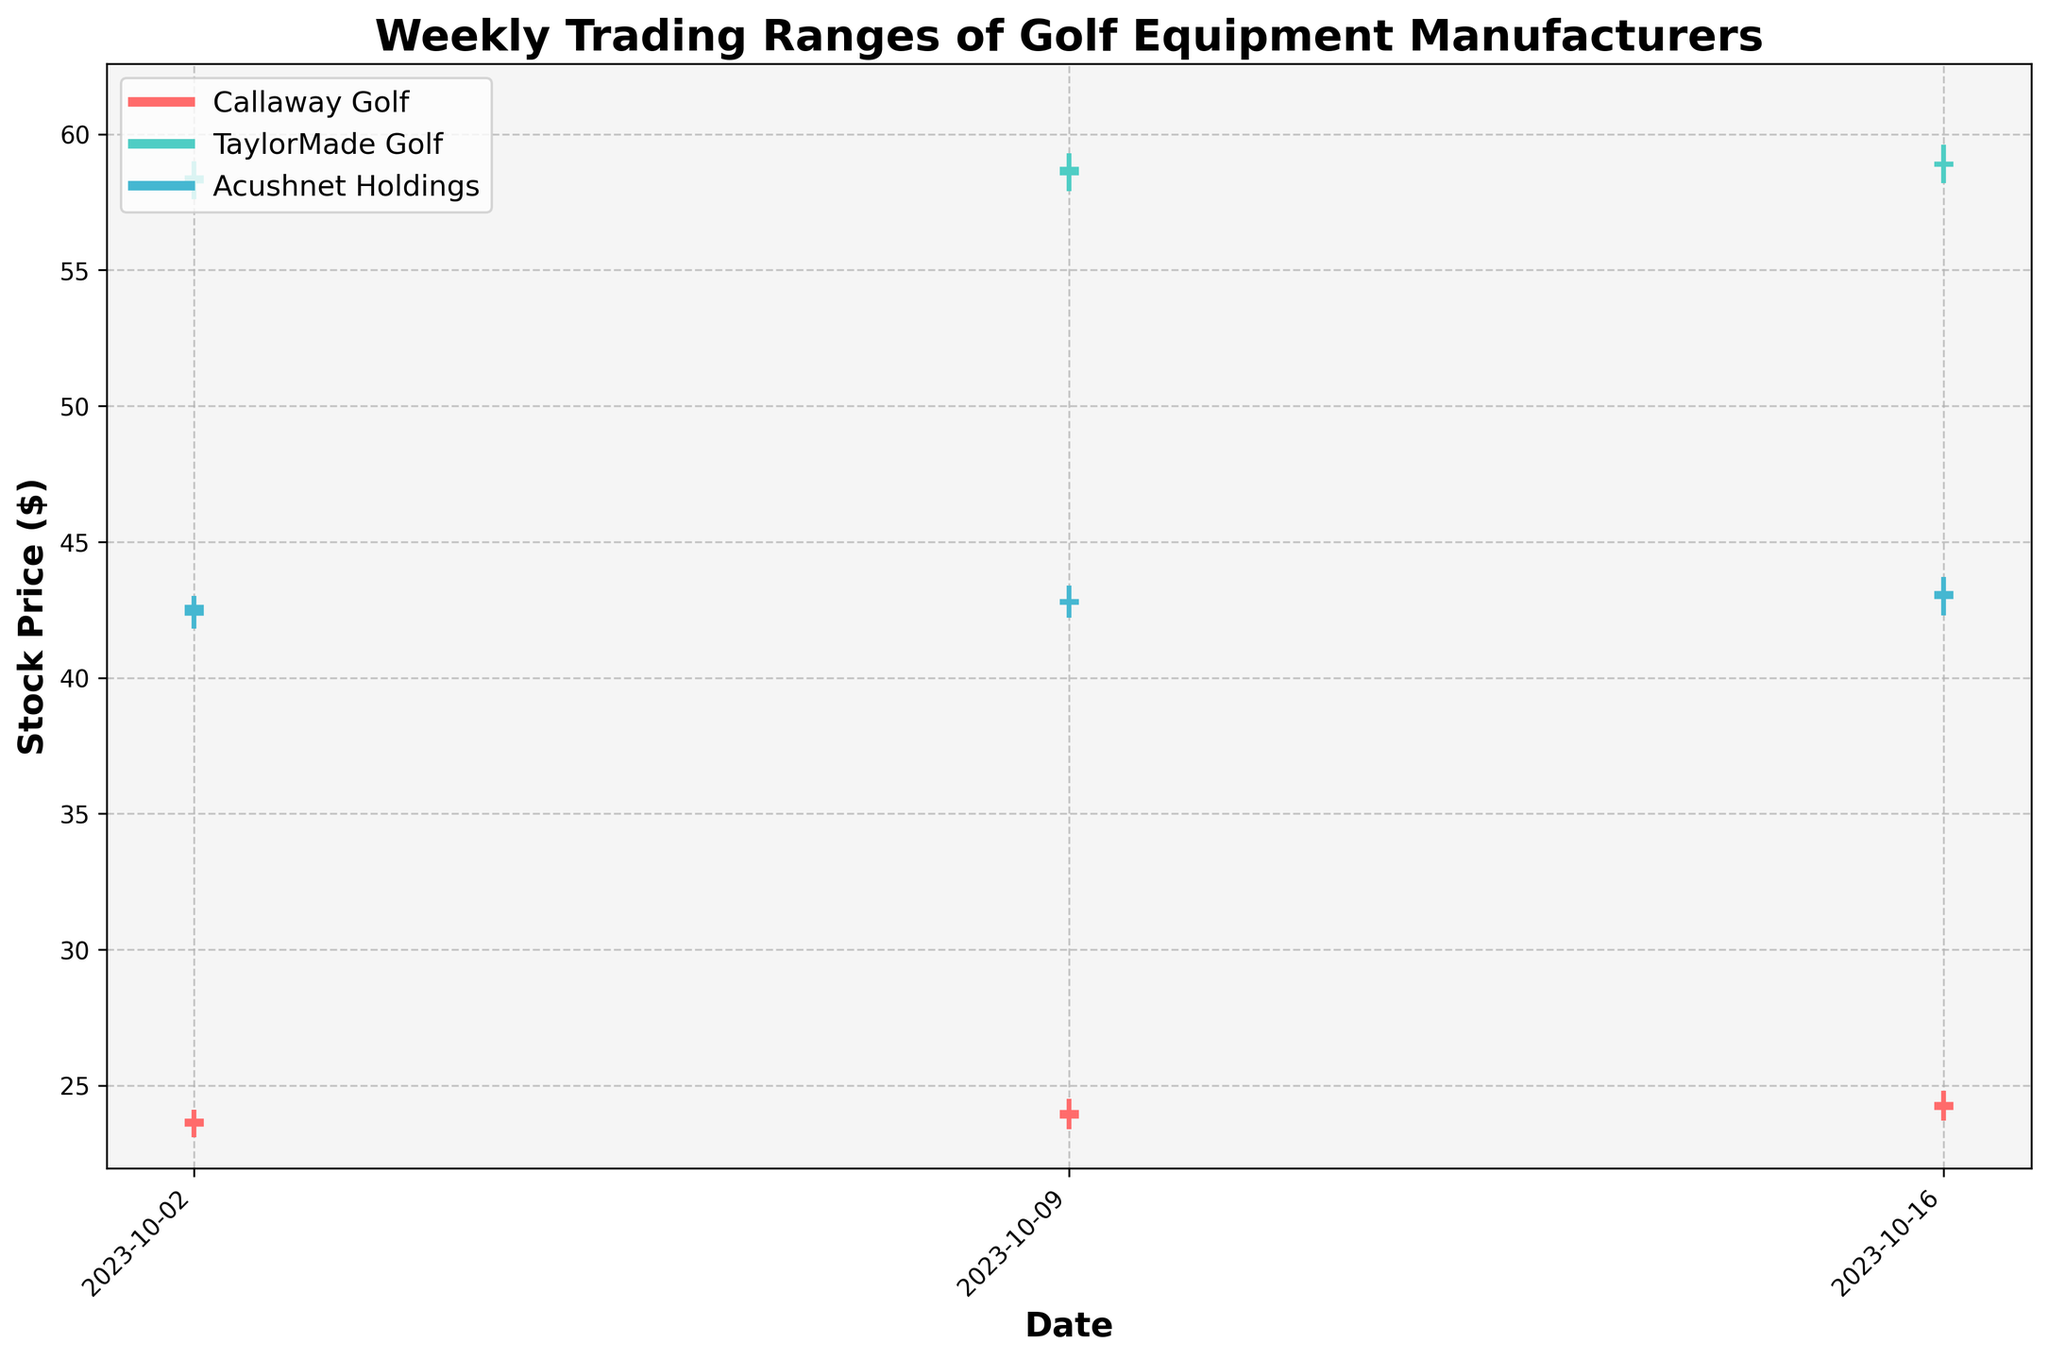What is the title of the candlestick plot? The title is usually placed at the top of the plot. In this case, the title is "Weekly Trading Ranges of Golf Equipment Manufacturers" to describe the subject of the plot.
Answer: Weekly Trading Ranges of Golf Equipment Manufacturers Which company had the highest closing price on October 16, 2023? To determine the highest closing price, look at the closing prices on October 16, 2023, for each company. The closing prices are 24.40 for Callaway Golf, 59.00 for TaylorMade Golf, and 43.20 for Acushnet Holdings. TaylorMade Golf has the highest closing price.
Answer: TaylorMade Golf What is the trading volume for Callaway Golf on October 9, 2023? The volume for each company on a specific date is usually shown in the data. On October 9, 2023, Callaway Golf's trading volume is listed as 130,000.
Answer: 130,000 Which date showed the narrowest trading range for Acushnet Holdings? To find the narrowest trading range, compute the difference between the High and Low prices for Acushnet Holdings on each date. The ranges are (43.00 - 41.80 = 1.20) on October 2, (43.40 - 42.20 = 1.20) on October 9, and (43.70 - 42.30 = 1.40) on October 16. The smallest range is 1.20, which occurs on both October 2 and October 9.
Answer: October 2 and 9 Compare the opening prices of TaylorMade Golf on October 2, October 9, and October 16, 2023, and identify the trend. The opening prices for TaylorMade Golf are 58.20 on October 2, 58.50 on October 9, and 58.80 on October 16. We observe that the opening price increased each week.
Answer: Increasing What is the average closing price of the three companies on October 9, 2023? Sum the closing prices for each company on October 9: 24.10 (Callaway) + 58.80 (TaylorMade) + 42.90 (Acushnet). The sum is 125.80. Divide by the number of companies (3) to get the average: 125.80 / 3 = 41.93.
Answer: 41.93 Which company had the highest weekly trading volume overall? Compare the total trading volumes for each company across all dates. Callaway Golf: 120000 + 130000 + 140000 = 390000, TaylorMade Golf: 95000 + 97000 + 100000 = 292000, Acushnet Holdings: 75000 + 76000 + 77000 = 228000. Callaway Golf has the highest overall volume.
Answer: Callaway Golf How many weeks of data are shown in the plot? Count the number of unique dates on the plot. There are three different dates shown: October 2, October 9, and October 16, 2023.
Answer: 3 For Acushnet Holdings, how does the closing price on October 16, 2023, compare to the closing price on October 9, 2023? Compare the closing prices. On October 16, the closing price was 43.20, while on October 9, it was 42.90. The closing price increased from October 9 to October 16.
Answer: Increased 